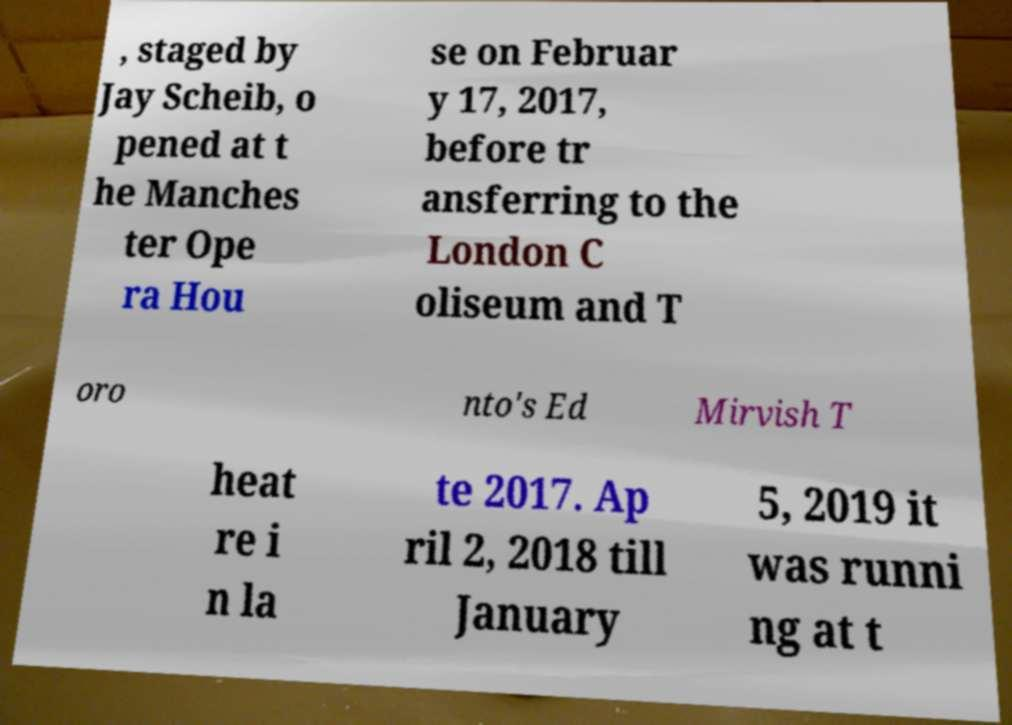Please identify and transcribe the text found in this image. , staged by Jay Scheib, o pened at t he Manches ter Ope ra Hou se on Februar y 17, 2017, before tr ansferring to the London C oliseum and T oro nto's Ed Mirvish T heat re i n la te 2017. Ap ril 2, 2018 till January 5, 2019 it was runni ng at t 